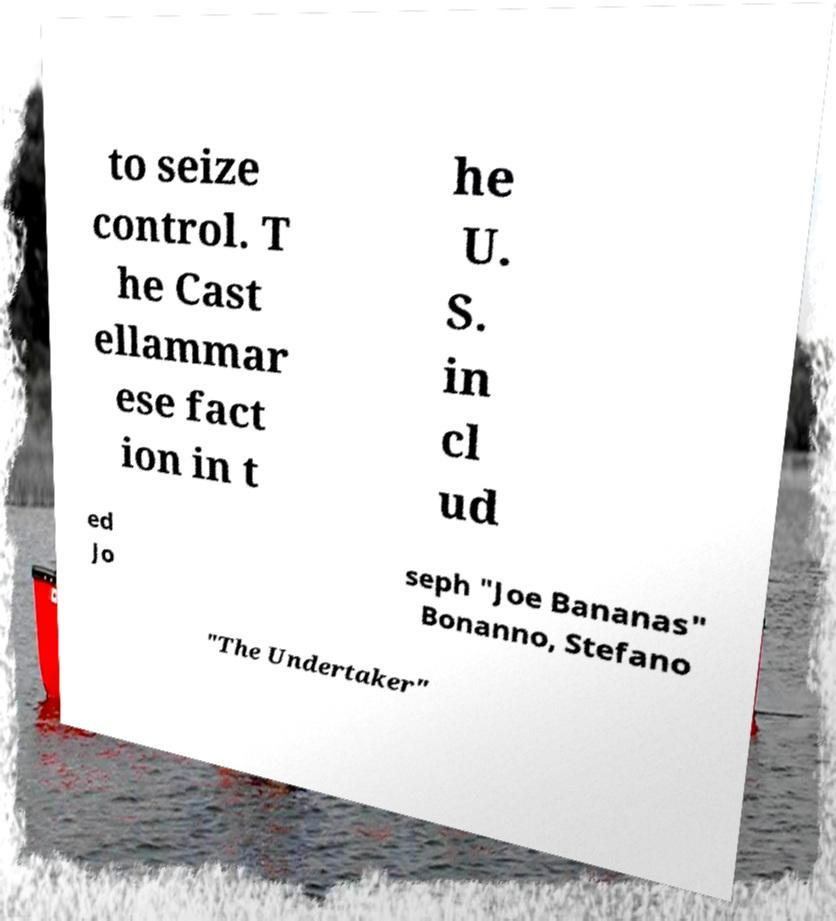What messages or text are displayed in this image? I need them in a readable, typed format. to seize control. T he Cast ellammar ese fact ion in t he U. S. in cl ud ed Jo seph "Joe Bananas" Bonanno, Stefano "The Undertaker" 